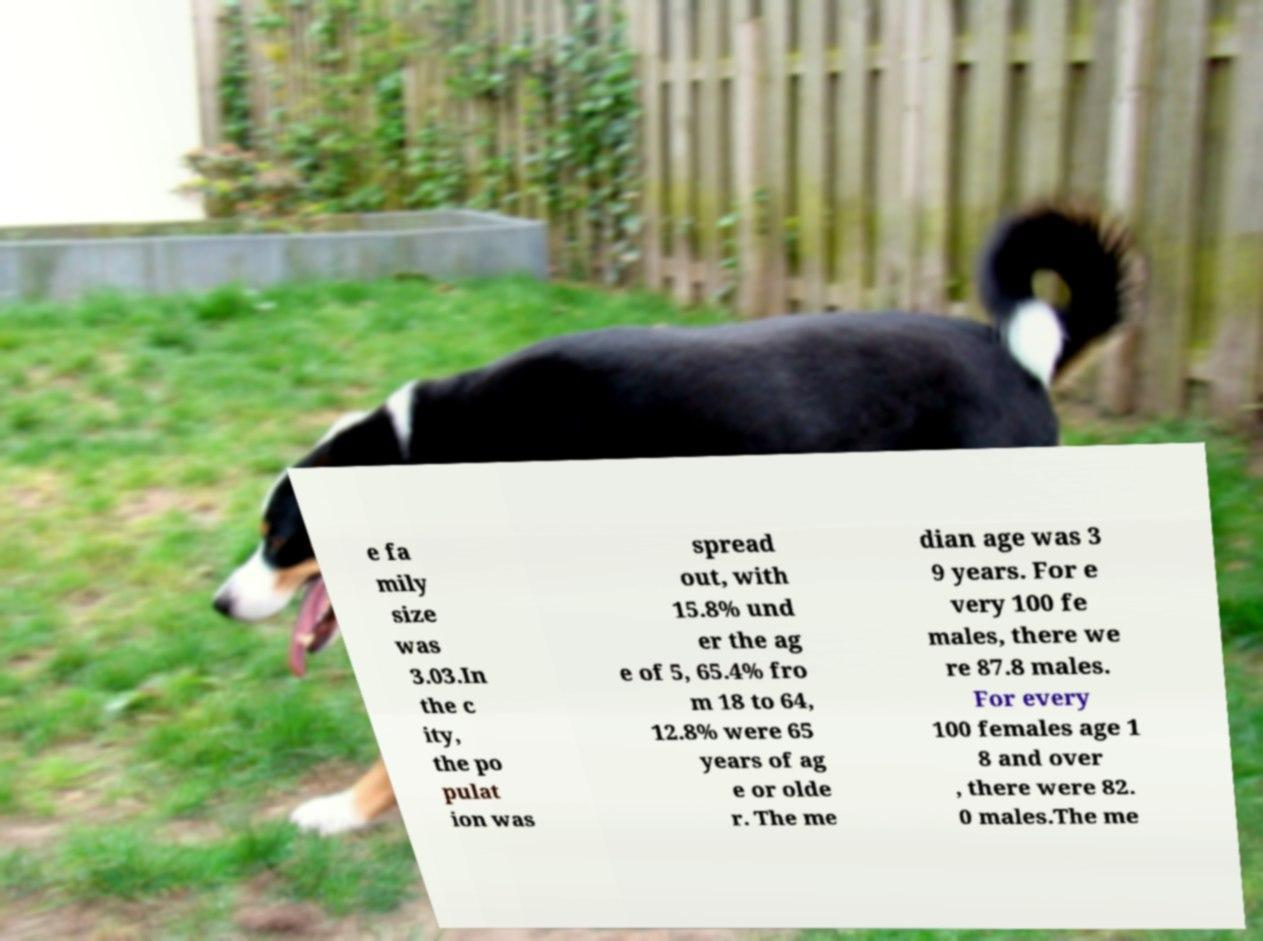I need the written content from this picture converted into text. Can you do that? e fa mily size was 3.03.In the c ity, the po pulat ion was spread out, with 15.8% und er the ag e of 5, 65.4% fro m 18 to 64, 12.8% were 65 years of ag e or olde r. The me dian age was 3 9 years. For e very 100 fe males, there we re 87.8 males. For every 100 females age 1 8 and over , there were 82. 0 males.The me 